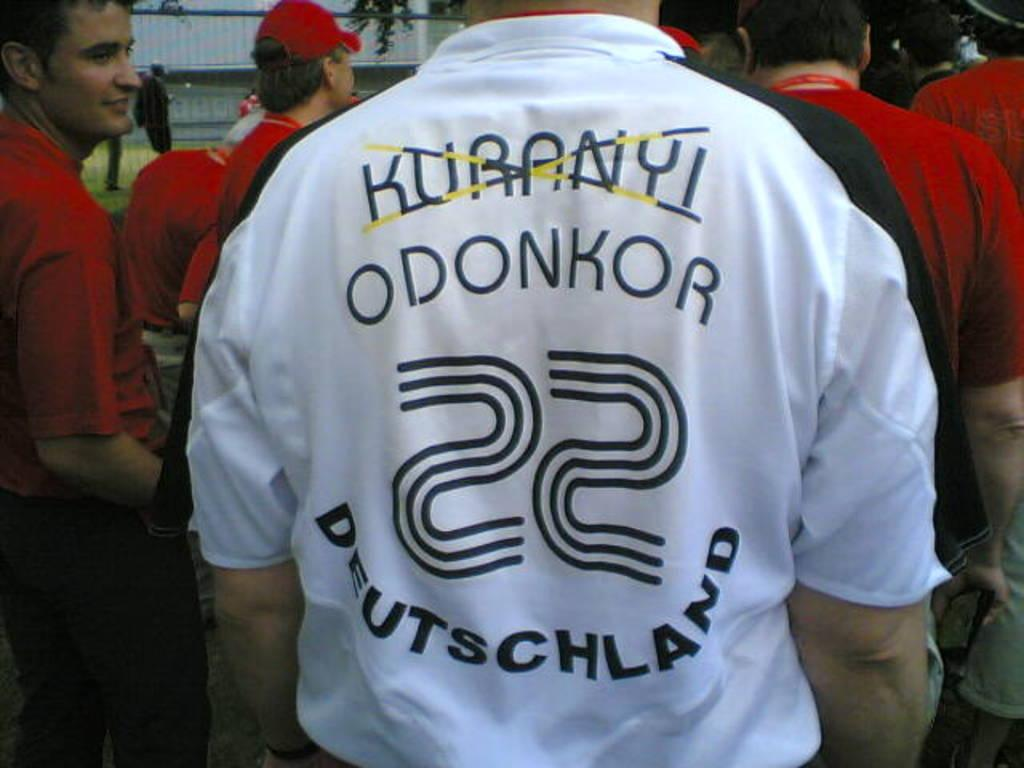<image>
Summarize the visual content of the image. Man wearing a white shirt that has the numbe 22 on it. 